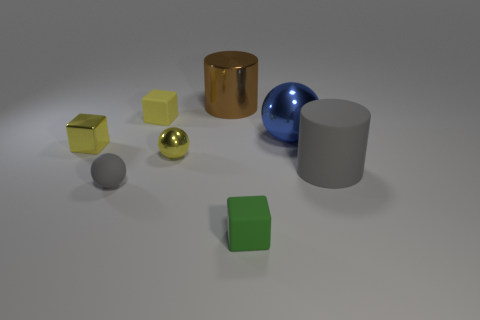What number of things are small yellow rubber balls or small spheres?
Give a very brief answer. 2. Are the big cylinder that is right of the tiny green block and the green cube made of the same material?
Give a very brief answer. Yes. How many objects are objects that are in front of the large brown shiny cylinder or tiny yellow spheres?
Keep it short and to the point. 7. There is a ball that is the same material as the big blue thing; what color is it?
Give a very brief answer. Yellow. Are there any yellow shiny things that have the same size as the metal block?
Offer a terse response. Yes. Is the color of the cube behind the tiny metal cube the same as the tiny metallic ball?
Your response must be concise. Yes. What color is the small block that is both behind the small gray thing and to the right of the small metal block?
Provide a short and direct response. Yellow. There is a brown thing that is the same size as the blue metallic ball; what is its shape?
Offer a terse response. Cylinder. Are there any metallic things that have the same shape as the tiny gray rubber thing?
Provide a succinct answer. Yes. Does the gray thing that is on the left side of the matte cylinder have the same size as the yellow ball?
Ensure brevity in your answer.  Yes. 